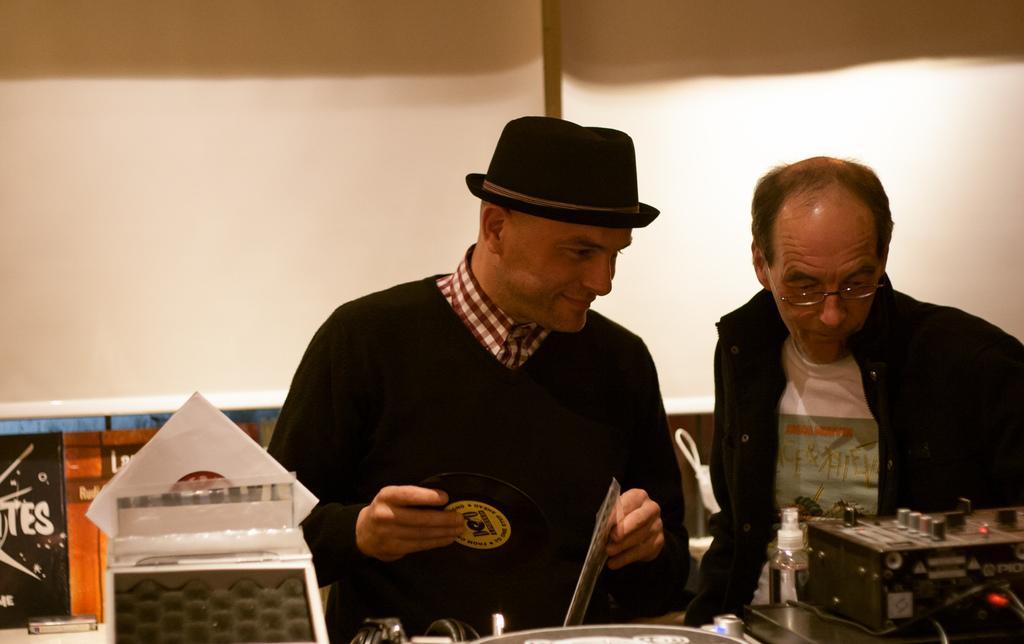In one or two sentences, can you explain what this image depicts? In the image there are two men, in front of them there is some equipment, the first person is holding some object in his hand and in the background there is a wall. 